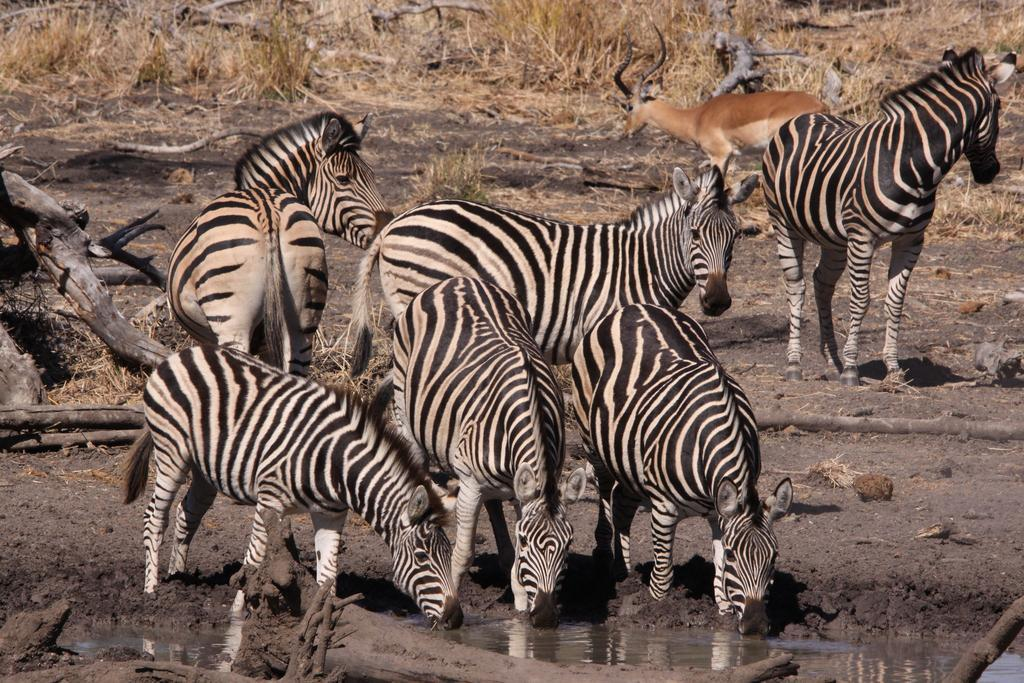What animals are present in the image? There is a group of zebras in the image. What is the condition of the ground where the zebras are standing? The zebras are standing on the muddy ground. What other animal can be seen in the background of the image? There is a deer visible in the background of the image. What type of vegetation is present in the background of the image? Dry grass is present in the background of the image. What is the name of the cub that is playing with the dime in the image? There is no cub or dime present in the image; it features a group of zebras and a deer in the background. 